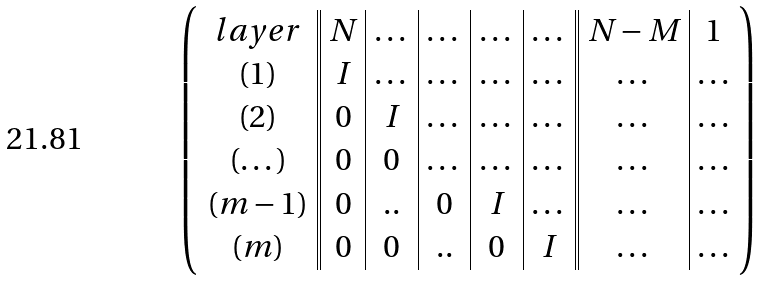Convert formula to latex. <formula><loc_0><loc_0><loc_500><loc_500>\left ( \begin{array} { c | | c | c | c | c | c | | c | c } l a y e r & N & \dots & \dots & \dots & \dots & N - M & 1 \\ ( 1 ) & I & \dots & \dots & \dots & \dots & \dots & \dots \\ ( 2 ) & 0 & I & \dots & \dots & \dots & \dots & \dots \\ ( \dots ) & 0 & 0 & \dots & \dots & \dots & \dots & \dots \\ ( m - 1 ) & 0 & . . & 0 & I & \dots & \dots & \dots \\ ( m ) & 0 & 0 & . . & 0 & I & \dots & \dots \\ \end{array} \right )</formula> 